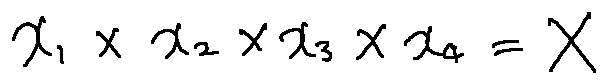<formula> <loc_0><loc_0><loc_500><loc_500>x _ { 1 } \times x _ { 2 } \times x _ { 3 } \times x _ { 4 } = X</formula> 